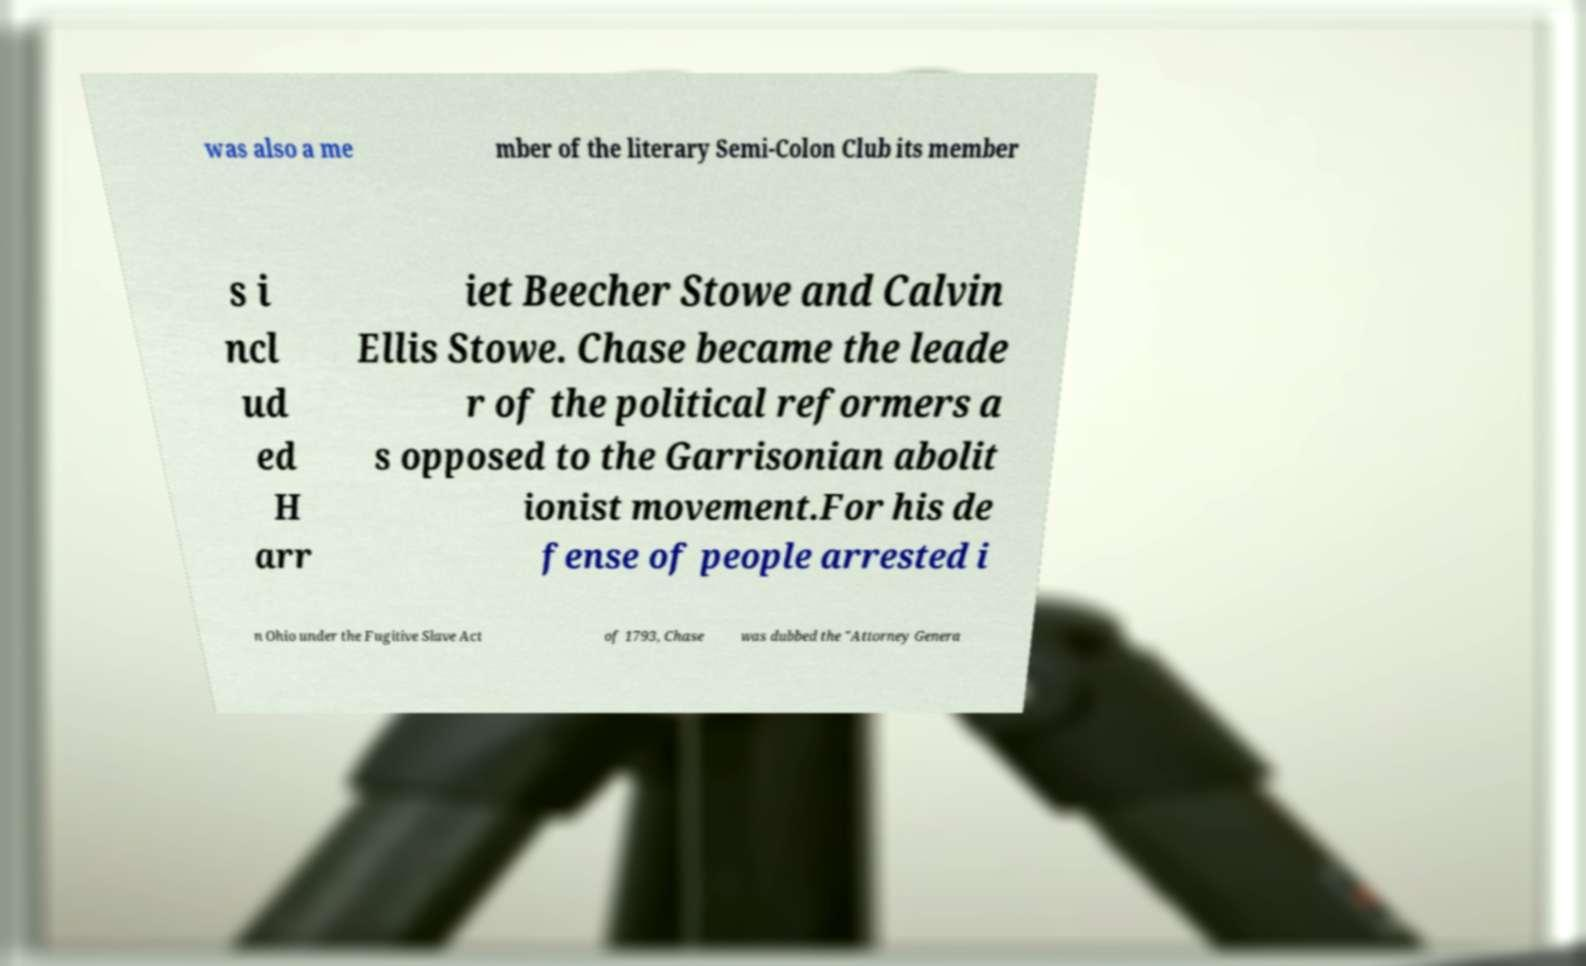Can you accurately transcribe the text from the provided image for me? was also a me mber of the literary Semi-Colon Club its member s i ncl ud ed H arr iet Beecher Stowe and Calvin Ellis Stowe. Chase became the leade r of the political reformers a s opposed to the Garrisonian abolit ionist movement.For his de fense of people arrested i n Ohio under the Fugitive Slave Act of 1793, Chase was dubbed the "Attorney Genera 